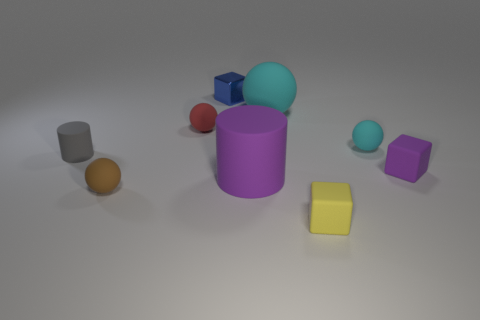There is a purple thing in front of the purple thing that is behind the cylinder that is to the right of the small blue shiny thing; what size is it?
Give a very brief answer. Large. Do the small ball on the left side of the small red ball and the big rubber ball have the same color?
Offer a very short reply. No. There is a purple thing that is the same shape as the gray thing; what size is it?
Your answer should be very brief. Large. How many things are small rubber blocks that are behind the small brown rubber ball or purple things that are right of the tiny yellow object?
Your answer should be very brief. 1. There is a purple matte thing that is right of the tiny ball that is right of the large cyan object; what shape is it?
Give a very brief answer. Cube. Are there any other things that are the same color as the small matte cylinder?
Keep it short and to the point. No. What number of things are either small cyan matte objects or tiny purple cubes?
Your answer should be very brief. 2. Are there any red shiny cylinders of the same size as the red rubber thing?
Offer a very short reply. No. What shape is the brown rubber thing?
Your answer should be compact. Sphere. Is the number of yellow rubber cubes that are left of the yellow matte block greater than the number of shiny objects that are behind the blue metal block?
Provide a short and direct response. No. 